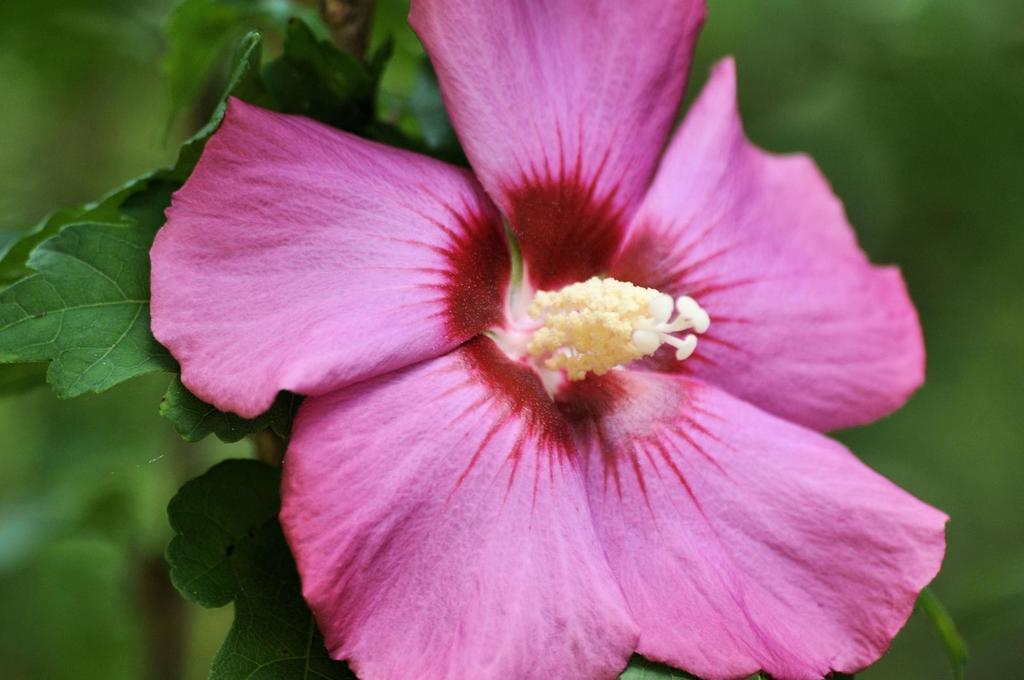What is the main subject of the image? The main subject of the image is a pink color flower. Where is the flower located in the image? The pink flower is in the center of the image. What can be seen in the background of the image? The background of the image includes leaves. What type of advice is the flower giving in the image? The flower is not giving any advice in the image, as it is an inanimate object and cannot speak or provide advice. 